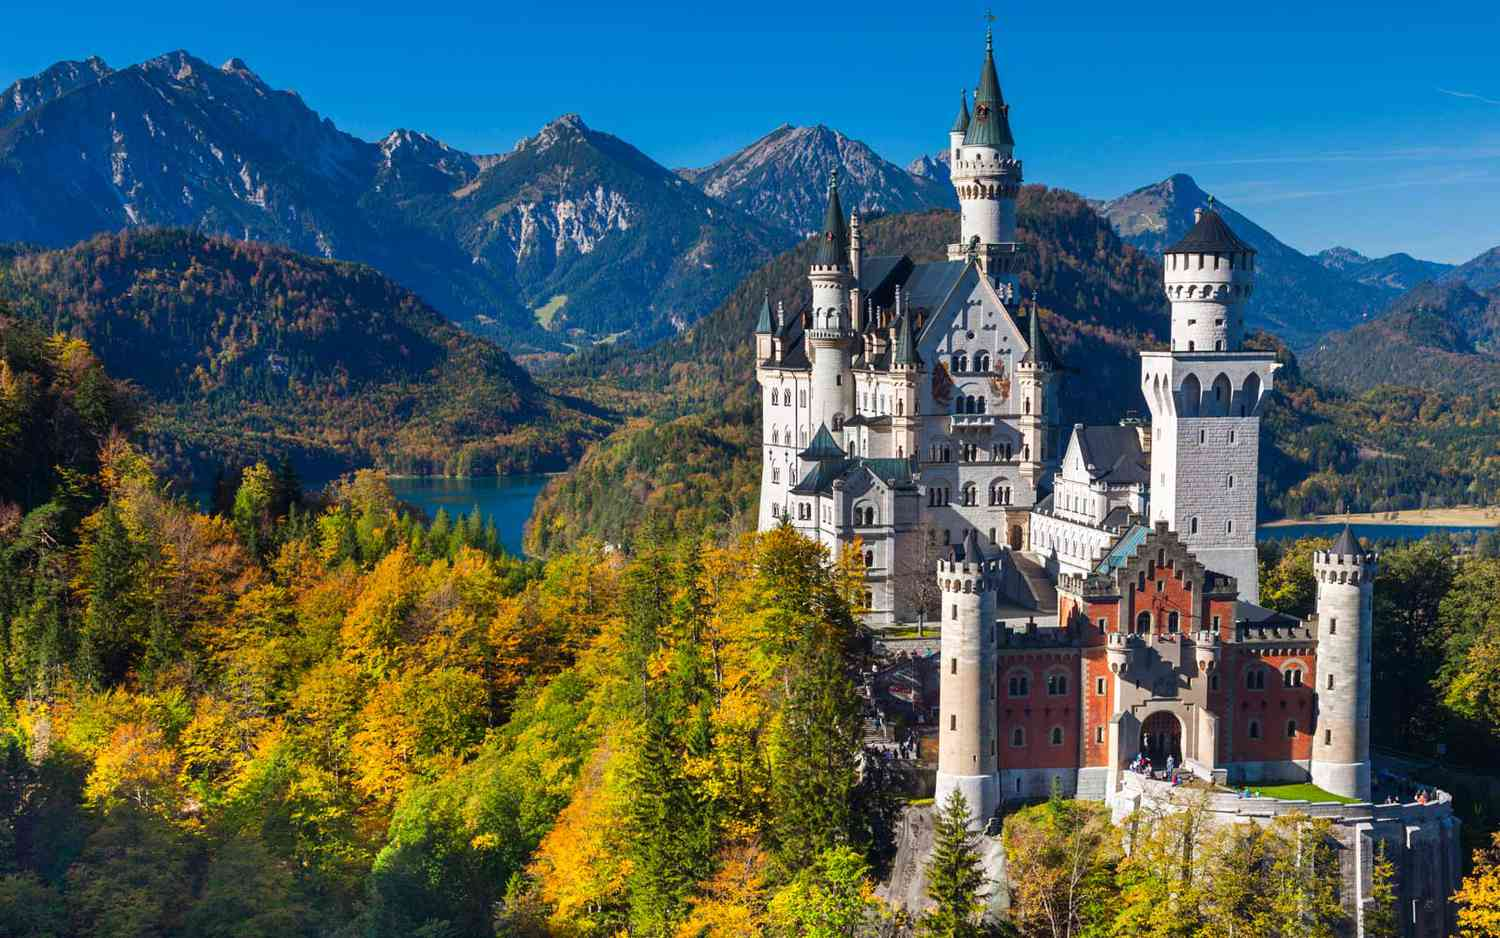What is the history behind Neuschwanstein Castle? Neuschwanstein Castle, commissioned by King Ludwig II of Bavaria, is a manifestation of the king's romantic vision and love for fairy tale-inspired architecture. Construction began in 1869, just two years after Ludwig ascended to the throne. The castle was intended as a personal retreat and homage to Ludwig's favorite composer, Richard Wagner, with many of its rooms and intricate details dedicated to the themes of his operas. Despite Ludwig’s grand ambitions, the castle remained unfinished at his death in 1886 under mysterious circumstances. Today, Neuschwanstein stands as an iconic symbol of fantasy architecture and draws visitors from around the world who are captivated by its story and its spectacular setting. What architectural styles are combined in the design of Neuschwanstein Castle? Neuschwanstein Castle is a masterpiece of eclectic design, combining several architectural styles that enhance its fairy-tale appearance. The primary style is Romanesque Revival, characterized by rounded arches, robust columns, and intricate stone carvings. Elements of Gothic Revival are evident in its pointed arches, ribbed vaults, and flying buttresses, giving it that dramatic flair typical of medieval gothic structures. Additionally, its interiors showcase the opulence of the Byzantine Revival style with ornate decorations, mosaics, and lavish frescoes that pay tribute to religious and historical themes. This blend of styles not only creates a visually stunning exterior but also enhances the narrative and thematic depth of its interiors. 